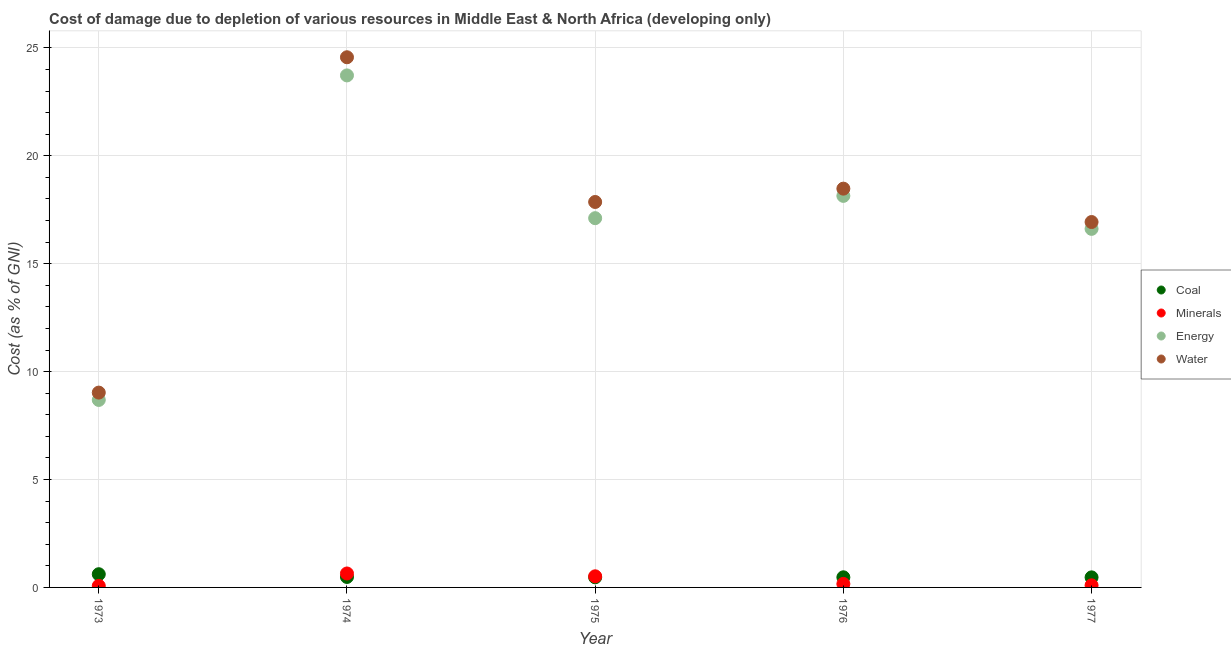How many different coloured dotlines are there?
Give a very brief answer. 4. Is the number of dotlines equal to the number of legend labels?
Ensure brevity in your answer.  Yes. What is the cost of damage due to depletion of water in 1976?
Offer a terse response. 18.48. Across all years, what is the maximum cost of damage due to depletion of water?
Give a very brief answer. 24.57. Across all years, what is the minimum cost of damage due to depletion of water?
Make the answer very short. 9.03. In which year was the cost of damage due to depletion of minerals maximum?
Keep it short and to the point. 1974. What is the total cost of damage due to depletion of energy in the graph?
Your answer should be very brief. 84.28. What is the difference between the cost of damage due to depletion of minerals in 1973 and that in 1974?
Provide a short and direct response. -0.57. What is the difference between the cost of damage due to depletion of energy in 1974 and the cost of damage due to depletion of minerals in 1976?
Keep it short and to the point. 23.56. What is the average cost of damage due to depletion of energy per year?
Make the answer very short. 16.86. In the year 1973, what is the difference between the cost of damage due to depletion of minerals and cost of damage due to depletion of water?
Make the answer very short. -8.96. What is the ratio of the cost of damage due to depletion of minerals in 1973 to that in 1977?
Keep it short and to the point. 0.74. Is the cost of damage due to depletion of water in 1975 less than that in 1977?
Ensure brevity in your answer.  No. Is the difference between the cost of damage due to depletion of minerals in 1974 and 1977 greater than the difference between the cost of damage due to depletion of coal in 1974 and 1977?
Ensure brevity in your answer.  Yes. What is the difference between the highest and the second highest cost of damage due to depletion of energy?
Your response must be concise. 5.58. What is the difference between the highest and the lowest cost of damage due to depletion of minerals?
Your response must be concise. 0.57. Is the sum of the cost of damage due to depletion of coal in 1973 and 1975 greater than the maximum cost of damage due to depletion of minerals across all years?
Keep it short and to the point. Yes. Is it the case that in every year, the sum of the cost of damage due to depletion of coal and cost of damage due to depletion of energy is greater than the sum of cost of damage due to depletion of minerals and cost of damage due to depletion of water?
Give a very brief answer. Yes. Is the cost of damage due to depletion of water strictly greater than the cost of damage due to depletion of minerals over the years?
Offer a terse response. Yes. Is the cost of damage due to depletion of coal strictly less than the cost of damage due to depletion of energy over the years?
Ensure brevity in your answer.  Yes. How many dotlines are there?
Offer a terse response. 4. What is the difference between two consecutive major ticks on the Y-axis?
Keep it short and to the point. 5. Are the values on the major ticks of Y-axis written in scientific E-notation?
Offer a very short reply. No. Does the graph contain grids?
Offer a terse response. Yes. Where does the legend appear in the graph?
Give a very brief answer. Center right. How many legend labels are there?
Make the answer very short. 4. How are the legend labels stacked?
Keep it short and to the point. Vertical. What is the title of the graph?
Provide a succinct answer. Cost of damage due to depletion of various resources in Middle East & North Africa (developing only) . Does "Other expenses" appear as one of the legend labels in the graph?
Make the answer very short. No. What is the label or title of the Y-axis?
Provide a succinct answer. Cost (as % of GNI). What is the Cost (as % of GNI) of Coal in 1973?
Offer a terse response. 0.61. What is the Cost (as % of GNI) in Minerals in 1973?
Your response must be concise. 0.07. What is the Cost (as % of GNI) of Energy in 1973?
Offer a terse response. 8.69. What is the Cost (as % of GNI) in Water in 1973?
Offer a very short reply. 9.03. What is the Cost (as % of GNI) in Coal in 1974?
Give a very brief answer. 0.48. What is the Cost (as % of GNI) of Minerals in 1974?
Provide a succinct answer. 0.65. What is the Cost (as % of GNI) of Energy in 1974?
Keep it short and to the point. 23.72. What is the Cost (as % of GNI) of Water in 1974?
Give a very brief answer. 24.57. What is the Cost (as % of GNI) of Coal in 1975?
Provide a short and direct response. 0.47. What is the Cost (as % of GNI) of Minerals in 1975?
Ensure brevity in your answer.  0.52. What is the Cost (as % of GNI) of Energy in 1975?
Your answer should be very brief. 17.11. What is the Cost (as % of GNI) of Water in 1975?
Provide a succinct answer. 17.86. What is the Cost (as % of GNI) of Coal in 1976?
Offer a very short reply. 0.47. What is the Cost (as % of GNI) in Minerals in 1976?
Offer a terse response. 0.16. What is the Cost (as % of GNI) of Energy in 1976?
Provide a short and direct response. 18.14. What is the Cost (as % of GNI) in Water in 1976?
Ensure brevity in your answer.  18.48. What is the Cost (as % of GNI) in Coal in 1977?
Your answer should be compact. 0.47. What is the Cost (as % of GNI) in Minerals in 1977?
Provide a succinct answer. 0.1. What is the Cost (as % of GNI) of Energy in 1977?
Make the answer very short. 16.61. What is the Cost (as % of GNI) of Water in 1977?
Offer a terse response. 16.93. Across all years, what is the maximum Cost (as % of GNI) of Coal?
Ensure brevity in your answer.  0.61. Across all years, what is the maximum Cost (as % of GNI) of Minerals?
Your answer should be compact. 0.65. Across all years, what is the maximum Cost (as % of GNI) of Energy?
Give a very brief answer. 23.72. Across all years, what is the maximum Cost (as % of GNI) in Water?
Give a very brief answer. 24.57. Across all years, what is the minimum Cost (as % of GNI) in Coal?
Ensure brevity in your answer.  0.47. Across all years, what is the minimum Cost (as % of GNI) of Minerals?
Your answer should be compact. 0.07. Across all years, what is the minimum Cost (as % of GNI) of Energy?
Keep it short and to the point. 8.69. Across all years, what is the minimum Cost (as % of GNI) in Water?
Offer a very short reply. 9.03. What is the total Cost (as % of GNI) in Coal in the graph?
Ensure brevity in your answer.  2.5. What is the total Cost (as % of GNI) in Minerals in the graph?
Provide a succinct answer. 1.49. What is the total Cost (as % of GNI) in Energy in the graph?
Your answer should be very brief. 84.28. What is the total Cost (as % of GNI) of Water in the graph?
Your answer should be compact. 86.86. What is the difference between the Cost (as % of GNI) of Coal in 1973 and that in 1974?
Offer a very short reply. 0.13. What is the difference between the Cost (as % of GNI) in Minerals in 1973 and that in 1974?
Provide a succinct answer. -0.57. What is the difference between the Cost (as % of GNI) of Energy in 1973 and that in 1974?
Make the answer very short. -15.04. What is the difference between the Cost (as % of GNI) of Water in 1973 and that in 1974?
Provide a short and direct response. -15.54. What is the difference between the Cost (as % of GNI) of Coal in 1973 and that in 1975?
Keep it short and to the point. 0.14. What is the difference between the Cost (as % of GNI) of Minerals in 1973 and that in 1975?
Your response must be concise. -0.44. What is the difference between the Cost (as % of GNI) in Energy in 1973 and that in 1975?
Offer a very short reply. -8.42. What is the difference between the Cost (as % of GNI) in Water in 1973 and that in 1975?
Keep it short and to the point. -8.83. What is the difference between the Cost (as % of GNI) of Coal in 1973 and that in 1976?
Keep it short and to the point. 0.14. What is the difference between the Cost (as % of GNI) of Minerals in 1973 and that in 1976?
Your answer should be very brief. -0.09. What is the difference between the Cost (as % of GNI) in Energy in 1973 and that in 1976?
Your answer should be compact. -9.46. What is the difference between the Cost (as % of GNI) of Water in 1973 and that in 1976?
Make the answer very short. -9.45. What is the difference between the Cost (as % of GNI) of Coal in 1973 and that in 1977?
Offer a terse response. 0.15. What is the difference between the Cost (as % of GNI) in Minerals in 1973 and that in 1977?
Provide a succinct answer. -0.03. What is the difference between the Cost (as % of GNI) in Energy in 1973 and that in 1977?
Ensure brevity in your answer.  -7.93. What is the difference between the Cost (as % of GNI) of Water in 1973 and that in 1977?
Give a very brief answer. -7.9. What is the difference between the Cost (as % of GNI) in Coal in 1974 and that in 1975?
Offer a terse response. 0.02. What is the difference between the Cost (as % of GNI) in Minerals in 1974 and that in 1975?
Provide a succinct answer. 0.13. What is the difference between the Cost (as % of GNI) in Energy in 1974 and that in 1975?
Offer a terse response. 6.62. What is the difference between the Cost (as % of GNI) in Water in 1974 and that in 1975?
Your answer should be compact. 6.71. What is the difference between the Cost (as % of GNI) of Coal in 1974 and that in 1976?
Your answer should be compact. 0.02. What is the difference between the Cost (as % of GNI) of Minerals in 1974 and that in 1976?
Your answer should be very brief. 0.48. What is the difference between the Cost (as % of GNI) of Energy in 1974 and that in 1976?
Make the answer very short. 5.58. What is the difference between the Cost (as % of GNI) in Water in 1974 and that in 1976?
Ensure brevity in your answer.  6.09. What is the difference between the Cost (as % of GNI) of Coal in 1974 and that in 1977?
Make the answer very short. 0.02. What is the difference between the Cost (as % of GNI) of Minerals in 1974 and that in 1977?
Provide a succinct answer. 0.55. What is the difference between the Cost (as % of GNI) of Energy in 1974 and that in 1977?
Provide a succinct answer. 7.11. What is the difference between the Cost (as % of GNI) of Water in 1974 and that in 1977?
Give a very brief answer. 7.64. What is the difference between the Cost (as % of GNI) in Coal in 1975 and that in 1976?
Provide a succinct answer. -0. What is the difference between the Cost (as % of GNI) in Minerals in 1975 and that in 1976?
Provide a succinct answer. 0.35. What is the difference between the Cost (as % of GNI) of Energy in 1975 and that in 1976?
Give a very brief answer. -1.03. What is the difference between the Cost (as % of GNI) of Water in 1975 and that in 1976?
Provide a succinct answer. -0.62. What is the difference between the Cost (as % of GNI) in Coal in 1975 and that in 1977?
Provide a succinct answer. 0. What is the difference between the Cost (as % of GNI) in Minerals in 1975 and that in 1977?
Your answer should be very brief. 0.42. What is the difference between the Cost (as % of GNI) in Energy in 1975 and that in 1977?
Your answer should be very brief. 0.5. What is the difference between the Cost (as % of GNI) in Water in 1975 and that in 1977?
Give a very brief answer. 0.93. What is the difference between the Cost (as % of GNI) in Coal in 1976 and that in 1977?
Your answer should be very brief. 0. What is the difference between the Cost (as % of GNI) of Minerals in 1976 and that in 1977?
Offer a very short reply. 0.07. What is the difference between the Cost (as % of GNI) in Energy in 1976 and that in 1977?
Offer a terse response. 1.53. What is the difference between the Cost (as % of GNI) of Water in 1976 and that in 1977?
Your answer should be compact. 1.55. What is the difference between the Cost (as % of GNI) of Coal in 1973 and the Cost (as % of GNI) of Minerals in 1974?
Offer a very short reply. -0.03. What is the difference between the Cost (as % of GNI) of Coal in 1973 and the Cost (as % of GNI) of Energy in 1974?
Your answer should be very brief. -23.11. What is the difference between the Cost (as % of GNI) in Coal in 1973 and the Cost (as % of GNI) in Water in 1974?
Offer a very short reply. -23.95. What is the difference between the Cost (as % of GNI) in Minerals in 1973 and the Cost (as % of GNI) in Energy in 1974?
Keep it short and to the point. -23.65. What is the difference between the Cost (as % of GNI) of Minerals in 1973 and the Cost (as % of GNI) of Water in 1974?
Your answer should be very brief. -24.49. What is the difference between the Cost (as % of GNI) of Energy in 1973 and the Cost (as % of GNI) of Water in 1974?
Offer a very short reply. -15.88. What is the difference between the Cost (as % of GNI) of Coal in 1973 and the Cost (as % of GNI) of Minerals in 1975?
Offer a very short reply. 0.1. What is the difference between the Cost (as % of GNI) in Coal in 1973 and the Cost (as % of GNI) in Energy in 1975?
Offer a terse response. -16.5. What is the difference between the Cost (as % of GNI) of Coal in 1973 and the Cost (as % of GNI) of Water in 1975?
Provide a succinct answer. -17.25. What is the difference between the Cost (as % of GNI) in Minerals in 1973 and the Cost (as % of GNI) in Energy in 1975?
Give a very brief answer. -17.04. What is the difference between the Cost (as % of GNI) in Minerals in 1973 and the Cost (as % of GNI) in Water in 1975?
Provide a succinct answer. -17.79. What is the difference between the Cost (as % of GNI) in Energy in 1973 and the Cost (as % of GNI) in Water in 1975?
Your answer should be very brief. -9.17. What is the difference between the Cost (as % of GNI) in Coal in 1973 and the Cost (as % of GNI) in Minerals in 1976?
Provide a succinct answer. 0.45. What is the difference between the Cost (as % of GNI) in Coal in 1973 and the Cost (as % of GNI) in Energy in 1976?
Make the answer very short. -17.53. What is the difference between the Cost (as % of GNI) in Coal in 1973 and the Cost (as % of GNI) in Water in 1976?
Keep it short and to the point. -17.86. What is the difference between the Cost (as % of GNI) of Minerals in 1973 and the Cost (as % of GNI) of Energy in 1976?
Offer a terse response. -18.07. What is the difference between the Cost (as % of GNI) of Minerals in 1973 and the Cost (as % of GNI) of Water in 1976?
Your response must be concise. -18.41. What is the difference between the Cost (as % of GNI) in Energy in 1973 and the Cost (as % of GNI) in Water in 1976?
Keep it short and to the point. -9.79. What is the difference between the Cost (as % of GNI) in Coal in 1973 and the Cost (as % of GNI) in Minerals in 1977?
Your answer should be very brief. 0.52. What is the difference between the Cost (as % of GNI) of Coal in 1973 and the Cost (as % of GNI) of Energy in 1977?
Ensure brevity in your answer.  -16. What is the difference between the Cost (as % of GNI) in Coal in 1973 and the Cost (as % of GNI) in Water in 1977?
Offer a terse response. -16.32. What is the difference between the Cost (as % of GNI) in Minerals in 1973 and the Cost (as % of GNI) in Energy in 1977?
Keep it short and to the point. -16.54. What is the difference between the Cost (as % of GNI) of Minerals in 1973 and the Cost (as % of GNI) of Water in 1977?
Ensure brevity in your answer.  -16.86. What is the difference between the Cost (as % of GNI) in Energy in 1973 and the Cost (as % of GNI) in Water in 1977?
Your answer should be very brief. -8.24. What is the difference between the Cost (as % of GNI) in Coal in 1974 and the Cost (as % of GNI) in Minerals in 1975?
Offer a very short reply. -0.03. What is the difference between the Cost (as % of GNI) of Coal in 1974 and the Cost (as % of GNI) of Energy in 1975?
Provide a short and direct response. -16.62. What is the difference between the Cost (as % of GNI) in Coal in 1974 and the Cost (as % of GNI) in Water in 1975?
Your response must be concise. -17.38. What is the difference between the Cost (as % of GNI) of Minerals in 1974 and the Cost (as % of GNI) of Energy in 1975?
Your answer should be compact. -16.46. What is the difference between the Cost (as % of GNI) in Minerals in 1974 and the Cost (as % of GNI) in Water in 1975?
Your answer should be compact. -17.21. What is the difference between the Cost (as % of GNI) of Energy in 1974 and the Cost (as % of GNI) of Water in 1975?
Ensure brevity in your answer.  5.86. What is the difference between the Cost (as % of GNI) in Coal in 1974 and the Cost (as % of GNI) in Minerals in 1976?
Keep it short and to the point. 0.32. What is the difference between the Cost (as % of GNI) of Coal in 1974 and the Cost (as % of GNI) of Energy in 1976?
Your response must be concise. -17.66. What is the difference between the Cost (as % of GNI) of Coal in 1974 and the Cost (as % of GNI) of Water in 1976?
Provide a short and direct response. -17.99. What is the difference between the Cost (as % of GNI) in Minerals in 1974 and the Cost (as % of GNI) in Energy in 1976?
Offer a very short reply. -17.5. What is the difference between the Cost (as % of GNI) in Minerals in 1974 and the Cost (as % of GNI) in Water in 1976?
Offer a very short reply. -17.83. What is the difference between the Cost (as % of GNI) of Energy in 1974 and the Cost (as % of GNI) of Water in 1976?
Provide a succinct answer. 5.25. What is the difference between the Cost (as % of GNI) in Coal in 1974 and the Cost (as % of GNI) in Minerals in 1977?
Keep it short and to the point. 0.39. What is the difference between the Cost (as % of GNI) in Coal in 1974 and the Cost (as % of GNI) in Energy in 1977?
Your response must be concise. -16.13. What is the difference between the Cost (as % of GNI) of Coal in 1974 and the Cost (as % of GNI) of Water in 1977?
Make the answer very short. -16.45. What is the difference between the Cost (as % of GNI) in Minerals in 1974 and the Cost (as % of GNI) in Energy in 1977?
Your answer should be compact. -15.97. What is the difference between the Cost (as % of GNI) of Minerals in 1974 and the Cost (as % of GNI) of Water in 1977?
Make the answer very short. -16.28. What is the difference between the Cost (as % of GNI) of Energy in 1974 and the Cost (as % of GNI) of Water in 1977?
Offer a very short reply. 6.79. What is the difference between the Cost (as % of GNI) in Coal in 1975 and the Cost (as % of GNI) in Minerals in 1976?
Keep it short and to the point. 0.31. What is the difference between the Cost (as % of GNI) in Coal in 1975 and the Cost (as % of GNI) in Energy in 1976?
Your answer should be very brief. -17.67. What is the difference between the Cost (as % of GNI) of Coal in 1975 and the Cost (as % of GNI) of Water in 1976?
Your answer should be very brief. -18.01. What is the difference between the Cost (as % of GNI) of Minerals in 1975 and the Cost (as % of GNI) of Energy in 1976?
Give a very brief answer. -17.63. What is the difference between the Cost (as % of GNI) in Minerals in 1975 and the Cost (as % of GNI) in Water in 1976?
Make the answer very short. -17.96. What is the difference between the Cost (as % of GNI) of Energy in 1975 and the Cost (as % of GNI) of Water in 1976?
Your answer should be very brief. -1.37. What is the difference between the Cost (as % of GNI) of Coal in 1975 and the Cost (as % of GNI) of Minerals in 1977?
Keep it short and to the point. 0.37. What is the difference between the Cost (as % of GNI) in Coal in 1975 and the Cost (as % of GNI) in Energy in 1977?
Offer a terse response. -16.15. What is the difference between the Cost (as % of GNI) in Coal in 1975 and the Cost (as % of GNI) in Water in 1977?
Offer a very short reply. -16.46. What is the difference between the Cost (as % of GNI) in Minerals in 1975 and the Cost (as % of GNI) in Energy in 1977?
Keep it short and to the point. -16.1. What is the difference between the Cost (as % of GNI) of Minerals in 1975 and the Cost (as % of GNI) of Water in 1977?
Keep it short and to the point. -16.41. What is the difference between the Cost (as % of GNI) of Energy in 1975 and the Cost (as % of GNI) of Water in 1977?
Make the answer very short. 0.18. What is the difference between the Cost (as % of GNI) in Coal in 1976 and the Cost (as % of GNI) in Minerals in 1977?
Give a very brief answer. 0.37. What is the difference between the Cost (as % of GNI) of Coal in 1976 and the Cost (as % of GNI) of Energy in 1977?
Give a very brief answer. -16.14. What is the difference between the Cost (as % of GNI) of Coal in 1976 and the Cost (as % of GNI) of Water in 1977?
Provide a succinct answer. -16.46. What is the difference between the Cost (as % of GNI) in Minerals in 1976 and the Cost (as % of GNI) in Energy in 1977?
Your response must be concise. -16.45. What is the difference between the Cost (as % of GNI) in Minerals in 1976 and the Cost (as % of GNI) in Water in 1977?
Provide a succinct answer. -16.77. What is the difference between the Cost (as % of GNI) in Energy in 1976 and the Cost (as % of GNI) in Water in 1977?
Offer a terse response. 1.21. What is the average Cost (as % of GNI) of Coal per year?
Your response must be concise. 0.5. What is the average Cost (as % of GNI) of Minerals per year?
Give a very brief answer. 0.3. What is the average Cost (as % of GNI) of Energy per year?
Keep it short and to the point. 16.86. What is the average Cost (as % of GNI) in Water per year?
Ensure brevity in your answer.  17.37. In the year 1973, what is the difference between the Cost (as % of GNI) of Coal and Cost (as % of GNI) of Minerals?
Offer a terse response. 0.54. In the year 1973, what is the difference between the Cost (as % of GNI) in Coal and Cost (as % of GNI) in Energy?
Your response must be concise. -8.07. In the year 1973, what is the difference between the Cost (as % of GNI) in Coal and Cost (as % of GNI) in Water?
Offer a terse response. -8.41. In the year 1973, what is the difference between the Cost (as % of GNI) in Minerals and Cost (as % of GNI) in Energy?
Your answer should be very brief. -8.62. In the year 1973, what is the difference between the Cost (as % of GNI) of Minerals and Cost (as % of GNI) of Water?
Your answer should be compact. -8.96. In the year 1973, what is the difference between the Cost (as % of GNI) of Energy and Cost (as % of GNI) of Water?
Make the answer very short. -0.34. In the year 1974, what is the difference between the Cost (as % of GNI) of Coal and Cost (as % of GNI) of Minerals?
Make the answer very short. -0.16. In the year 1974, what is the difference between the Cost (as % of GNI) in Coal and Cost (as % of GNI) in Energy?
Provide a short and direct response. -23.24. In the year 1974, what is the difference between the Cost (as % of GNI) in Coal and Cost (as % of GNI) in Water?
Provide a short and direct response. -24.08. In the year 1974, what is the difference between the Cost (as % of GNI) of Minerals and Cost (as % of GNI) of Energy?
Make the answer very short. -23.08. In the year 1974, what is the difference between the Cost (as % of GNI) of Minerals and Cost (as % of GNI) of Water?
Your answer should be compact. -23.92. In the year 1974, what is the difference between the Cost (as % of GNI) of Energy and Cost (as % of GNI) of Water?
Ensure brevity in your answer.  -0.84. In the year 1975, what is the difference between the Cost (as % of GNI) in Coal and Cost (as % of GNI) in Minerals?
Your answer should be compact. -0.05. In the year 1975, what is the difference between the Cost (as % of GNI) in Coal and Cost (as % of GNI) in Energy?
Provide a short and direct response. -16.64. In the year 1975, what is the difference between the Cost (as % of GNI) in Coal and Cost (as % of GNI) in Water?
Provide a short and direct response. -17.39. In the year 1975, what is the difference between the Cost (as % of GNI) in Minerals and Cost (as % of GNI) in Energy?
Your answer should be compact. -16.59. In the year 1975, what is the difference between the Cost (as % of GNI) of Minerals and Cost (as % of GNI) of Water?
Provide a succinct answer. -17.34. In the year 1975, what is the difference between the Cost (as % of GNI) of Energy and Cost (as % of GNI) of Water?
Make the answer very short. -0.75. In the year 1976, what is the difference between the Cost (as % of GNI) in Coal and Cost (as % of GNI) in Minerals?
Ensure brevity in your answer.  0.31. In the year 1976, what is the difference between the Cost (as % of GNI) of Coal and Cost (as % of GNI) of Energy?
Make the answer very short. -17.67. In the year 1976, what is the difference between the Cost (as % of GNI) in Coal and Cost (as % of GNI) in Water?
Your response must be concise. -18.01. In the year 1976, what is the difference between the Cost (as % of GNI) in Minerals and Cost (as % of GNI) in Energy?
Provide a succinct answer. -17.98. In the year 1976, what is the difference between the Cost (as % of GNI) in Minerals and Cost (as % of GNI) in Water?
Ensure brevity in your answer.  -18.31. In the year 1976, what is the difference between the Cost (as % of GNI) of Energy and Cost (as % of GNI) of Water?
Ensure brevity in your answer.  -0.33. In the year 1977, what is the difference between the Cost (as % of GNI) of Coal and Cost (as % of GNI) of Minerals?
Give a very brief answer. 0.37. In the year 1977, what is the difference between the Cost (as % of GNI) of Coal and Cost (as % of GNI) of Energy?
Offer a very short reply. -16.15. In the year 1977, what is the difference between the Cost (as % of GNI) of Coal and Cost (as % of GNI) of Water?
Offer a very short reply. -16.46. In the year 1977, what is the difference between the Cost (as % of GNI) in Minerals and Cost (as % of GNI) in Energy?
Make the answer very short. -16.52. In the year 1977, what is the difference between the Cost (as % of GNI) in Minerals and Cost (as % of GNI) in Water?
Keep it short and to the point. -16.83. In the year 1977, what is the difference between the Cost (as % of GNI) of Energy and Cost (as % of GNI) of Water?
Keep it short and to the point. -0.32. What is the ratio of the Cost (as % of GNI) in Coal in 1973 to that in 1974?
Provide a short and direct response. 1.26. What is the ratio of the Cost (as % of GNI) in Minerals in 1973 to that in 1974?
Provide a succinct answer. 0.11. What is the ratio of the Cost (as % of GNI) in Energy in 1973 to that in 1974?
Offer a very short reply. 0.37. What is the ratio of the Cost (as % of GNI) of Water in 1973 to that in 1974?
Your response must be concise. 0.37. What is the ratio of the Cost (as % of GNI) in Coal in 1973 to that in 1975?
Make the answer very short. 1.31. What is the ratio of the Cost (as % of GNI) of Minerals in 1973 to that in 1975?
Make the answer very short. 0.14. What is the ratio of the Cost (as % of GNI) of Energy in 1973 to that in 1975?
Keep it short and to the point. 0.51. What is the ratio of the Cost (as % of GNI) of Water in 1973 to that in 1975?
Ensure brevity in your answer.  0.51. What is the ratio of the Cost (as % of GNI) in Coal in 1973 to that in 1976?
Ensure brevity in your answer.  1.31. What is the ratio of the Cost (as % of GNI) of Minerals in 1973 to that in 1976?
Offer a terse response. 0.44. What is the ratio of the Cost (as % of GNI) of Energy in 1973 to that in 1976?
Your answer should be compact. 0.48. What is the ratio of the Cost (as % of GNI) in Water in 1973 to that in 1976?
Provide a succinct answer. 0.49. What is the ratio of the Cost (as % of GNI) of Coal in 1973 to that in 1977?
Your answer should be compact. 1.31. What is the ratio of the Cost (as % of GNI) in Minerals in 1973 to that in 1977?
Offer a very short reply. 0.74. What is the ratio of the Cost (as % of GNI) in Energy in 1973 to that in 1977?
Offer a very short reply. 0.52. What is the ratio of the Cost (as % of GNI) of Water in 1973 to that in 1977?
Your answer should be very brief. 0.53. What is the ratio of the Cost (as % of GNI) in Coal in 1974 to that in 1975?
Your response must be concise. 1.03. What is the ratio of the Cost (as % of GNI) in Minerals in 1974 to that in 1975?
Provide a succinct answer. 1.25. What is the ratio of the Cost (as % of GNI) of Energy in 1974 to that in 1975?
Offer a terse response. 1.39. What is the ratio of the Cost (as % of GNI) of Water in 1974 to that in 1975?
Offer a very short reply. 1.38. What is the ratio of the Cost (as % of GNI) of Coal in 1974 to that in 1976?
Provide a succinct answer. 1.03. What is the ratio of the Cost (as % of GNI) of Minerals in 1974 to that in 1976?
Your answer should be compact. 3.97. What is the ratio of the Cost (as % of GNI) in Energy in 1974 to that in 1976?
Offer a terse response. 1.31. What is the ratio of the Cost (as % of GNI) in Water in 1974 to that in 1976?
Your answer should be compact. 1.33. What is the ratio of the Cost (as % of GNI) in Coal in 1974 to that in 1977?
Your answer should be very brief. 1.04. What is the ratio of the Cost (as % of GNI) of Minerals in 1974 to that in 1977?
Provide a succinct answer. 6.65. What is the ratio of the Cost (as % of GNI) in Energy in 1974 to that in 1977?
Give a very brief answer. 1.43. What is the ratio of the Cost (as % of GNI) of Water in 1974 to that in 1977?
Keep it short and to the point. 1.45. What is the ratio of the Cost (as % of GNI) of Minerals in 1975 to that in 1976?
Give a very brief answer. 3.17. What is the ratio of the Cost (as % of GNI) in Energy in 1975 to that in 1976?
Provide a succinct answer. 0.94. What is the ratio of the Cost (as % of GNI) in Water in 1975 to that in 1976?
Make the answer very short. 0.97. What is the ratio of the Cost (as % of GNI) of Coal in 1975 to that in 1977?
Ensure brevity in your answer.  1.01. What is the ratio of the Cost (as % of GNI) of Minerals in 1975 to that in 1977?
Make the answer very short. 5.3. What is the ratio of the Cost (as % of GNI) of Energy in 1975 to that in 1977?
Make the answer very short. 1.03. What is the ratio of the Cost (as % of GNI) in Water in 1975 to that in 1977?
Ensure brevity in your answer.  1.05. What is the ratio of the Cost (as % of GNI) in Coal in 1976 to that in 1977?
Give a very brief answer. 1.01. What is the ratio of the Cost (as % of GNI) in Minerals in 1976 to that in 1977?
Make the answer very short. 1.68. What is the ratio of the Cost (as % of GNI) in Energy in 1976 to that in 1977?
Give a very brief answer. 1.09. What is the ratio of the Cost (as % of GNI) of Water in 1976 to that in 1977?
Offer a terse response. 1.09. What is the difference between the highest and the second highest Cost (as % of GNI) of Coal?
Offer a terse response. 0.13. What is the difference between the highest and the second highest Cost (as % of GNI) in Minerals?
Provide a succinct answer. 0.13. What is the difference between the highest and the second highest Cost (as % of GNI) in Energy?
Keep it short and to the point. 5.58. What is the difference between the highest and the second highest Cost (as % of GNI) in Water?
Keep it short and to the point. 6.09. What is the difference between the highest and the lowest Cost (as % of GNI) of Coal?
Ensure brevity in your answer.  0.15. What is the difference between the highest and the lowest Cost (as % of GNI) in Minerals?
Your response must be concise. 0.57. What is the difference between the highest and the lowest Cost (as % of GNI) in Energy?
Provide a succinct answer. 15.04. What is the difference between the highest and the lowest Cost (as % of GNI) of Water?
Keep it short and to the point. 15.54. 